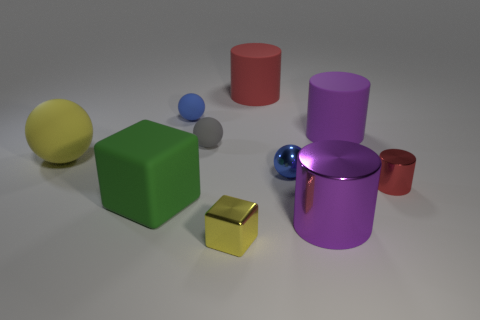Subtract all purple metal cylinders. How many cylinders are left? 3 Subtract all gray cubes. How many purple cylinders are left? 2 Subtract 2 cylinders. How many cylinders are left? 2 Subtract all gray balls. How many balls are left? 3 Subtract all cylinders. How many objects are left? 6 Subtract 0 purple spheres. How many objects are left? 10 Subtract all purple balls. Subtract all blue blocks. How many balls are left? 4 Subtract all tiny cylinders. Subtract all big red rubber things. How many objects are left? 8 Add 2 blue balls. How many blue balls are left? 4 Add 4 large cylinders. How many large cylinders exist? 7 